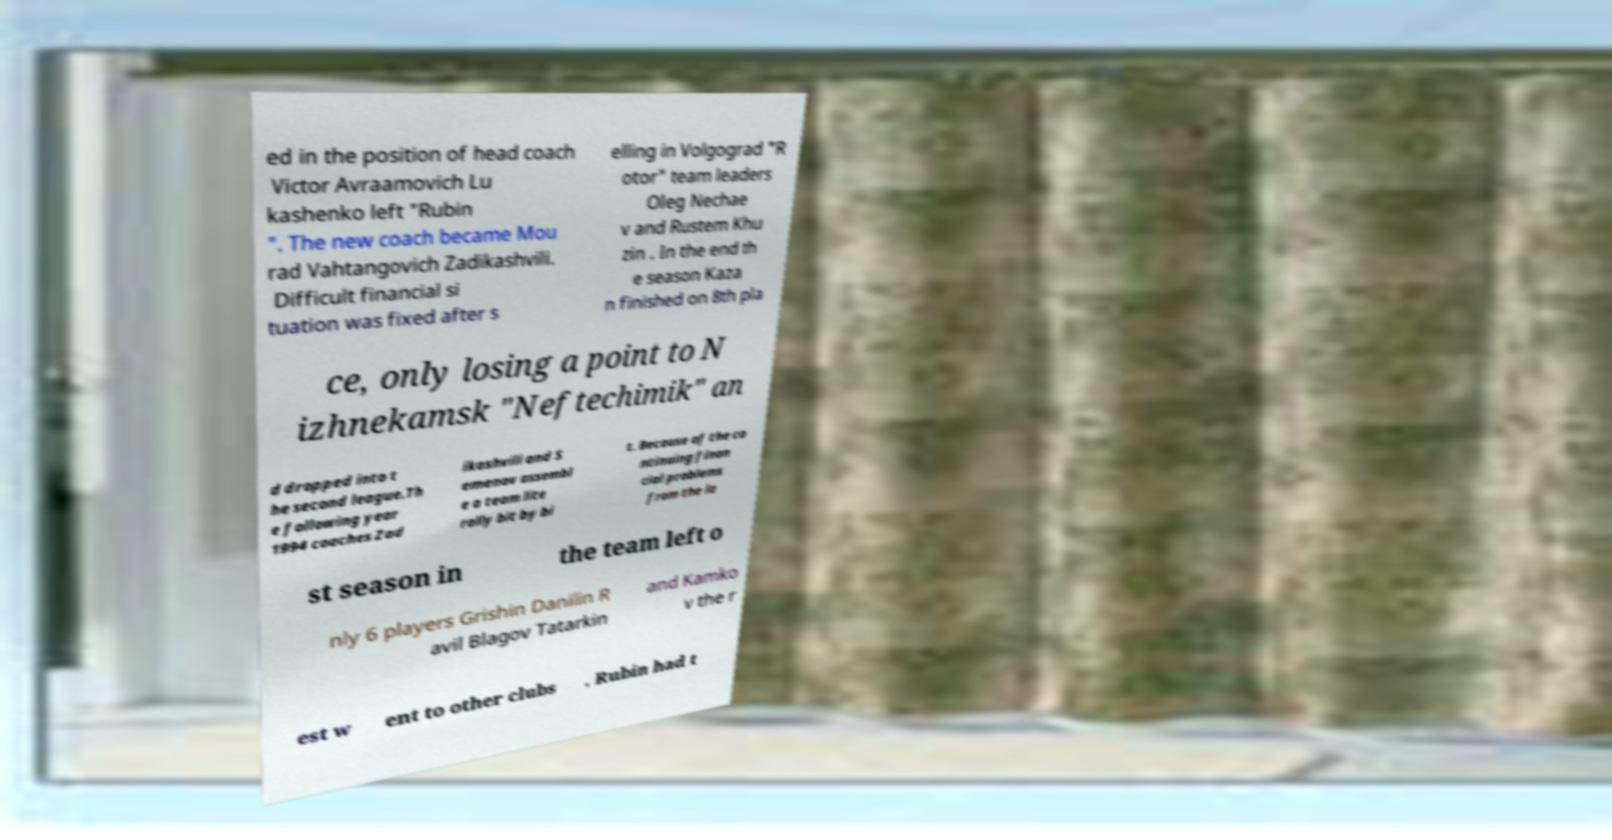There's text embedded in this image that I need extracted. Can you transcribe it verbatim? ed in the position of head coach Victor Avraamovich Lu kashenko left "Rubin ". The new coach became Mou rad Vahtangovich Zadikashvili. Difficult financial si tuation was fixed after s elling in Volgograd "R otor" team leaders Oleg Nechae v and Rustem Khu zin . In the end th e season Kaza n finished on 8th pla ce, only losing a point to N izhnekamsk "Neftechimik" an d dropped into t he second league.Th e following year 1994 coaches Zad ikashvili and S emenov assembl e a team lite rally bit by bi t. Because of the co ntinuing finan cial problems from the la st season in the team left o nly 6 players Grishin Danilin R avil Blagov Tatarkin and Kamko v the r est w ent to other clubs . Rubin had t 